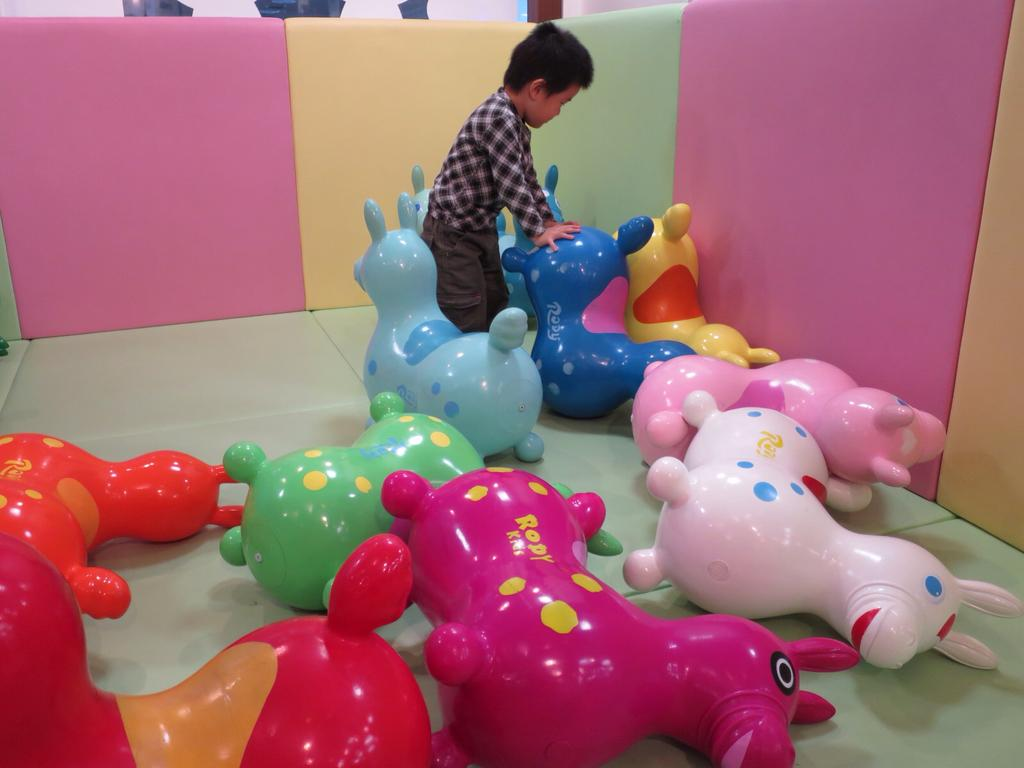What is the main subject of the image? The main subject of the image is a kid. What is the kid doing in the image? The kid is playing with toys in the image. Can you describe the toys the kid is playing with? The toys are in different colors. What can be seen in the background of the image? There is a wall in the image, and it has different colors. How many chairs are visible in the image? There are no chairs visible in the image. What type of club is the kid a member of in the image? There is no club mentioned or depicted in the image. 